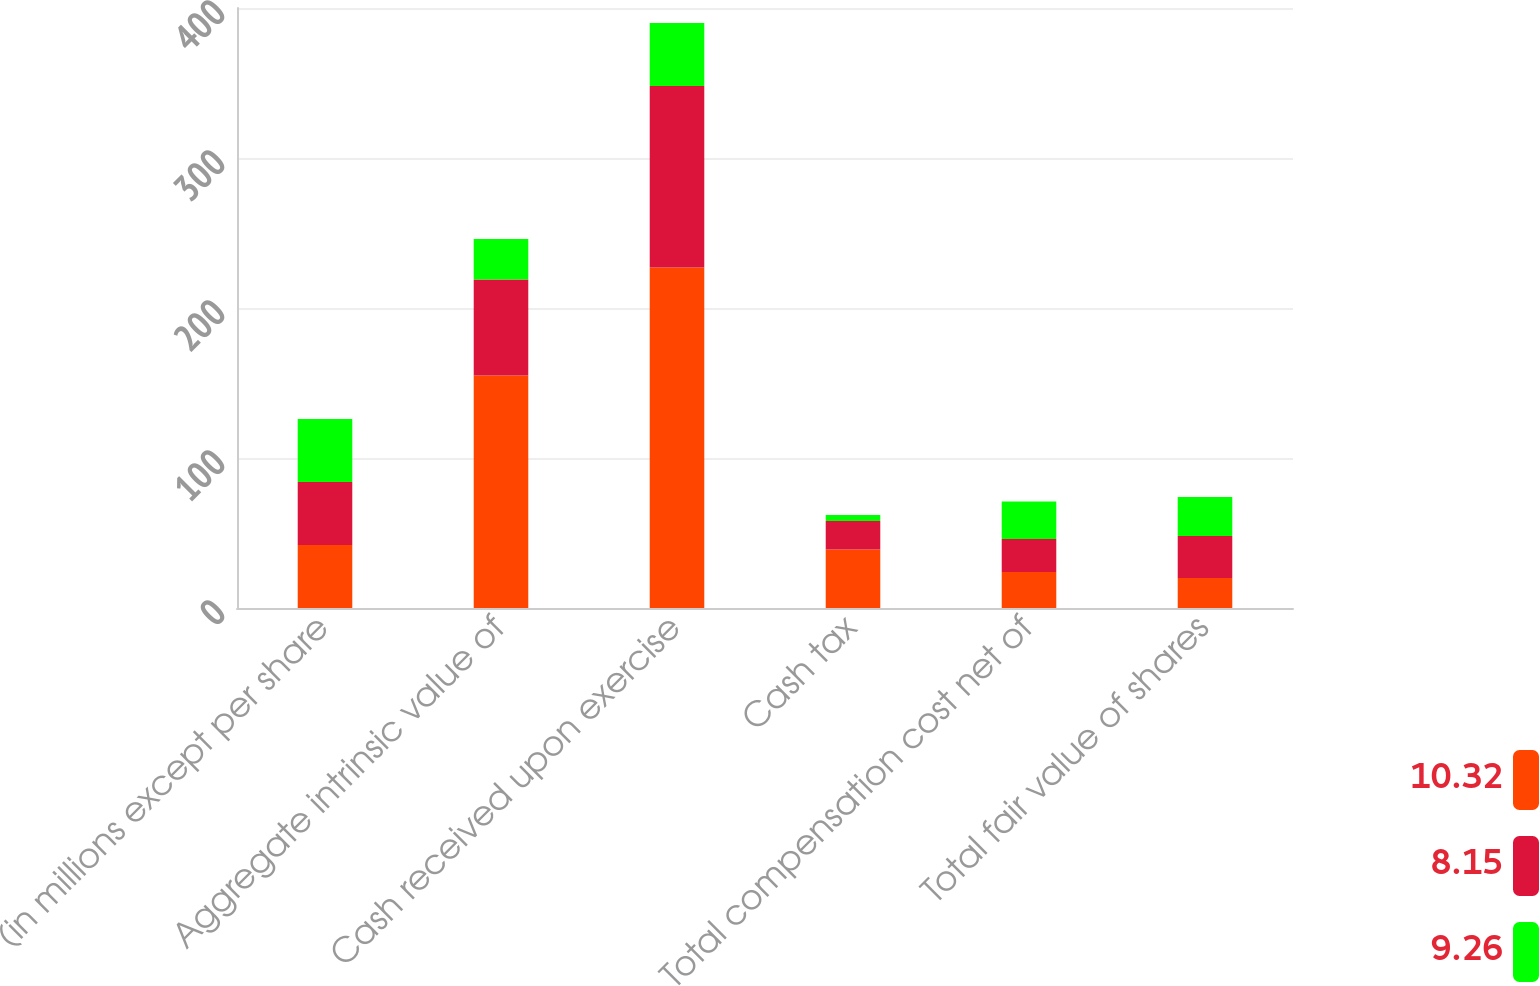Convert chart to OTSL. <chart><loc_0><loc_0><loc_500><loc_500><stacked_bar_chart><ecel><fcel>(in millions except per share<fcel>Aggregate intrinsic value of<fcel>Cash received upon exercise<fcel>Cash tax<fcel>Total compensation cost net of<fcel>Total fair value of shares<nl><fcel>10.32<fcel>42<fcel>155<fcel>227<fcel>39<fcel>24<fcel>20<nl><fcel>8.15<fcel>42<fcel>64<fcel>121<fcel>19<fcel>22<fcel>28<nl><fcel>9.26<fcel>42<fcel>27<fcel>42<fcel>4<fcel>25<fcel>26<nl></chart> 